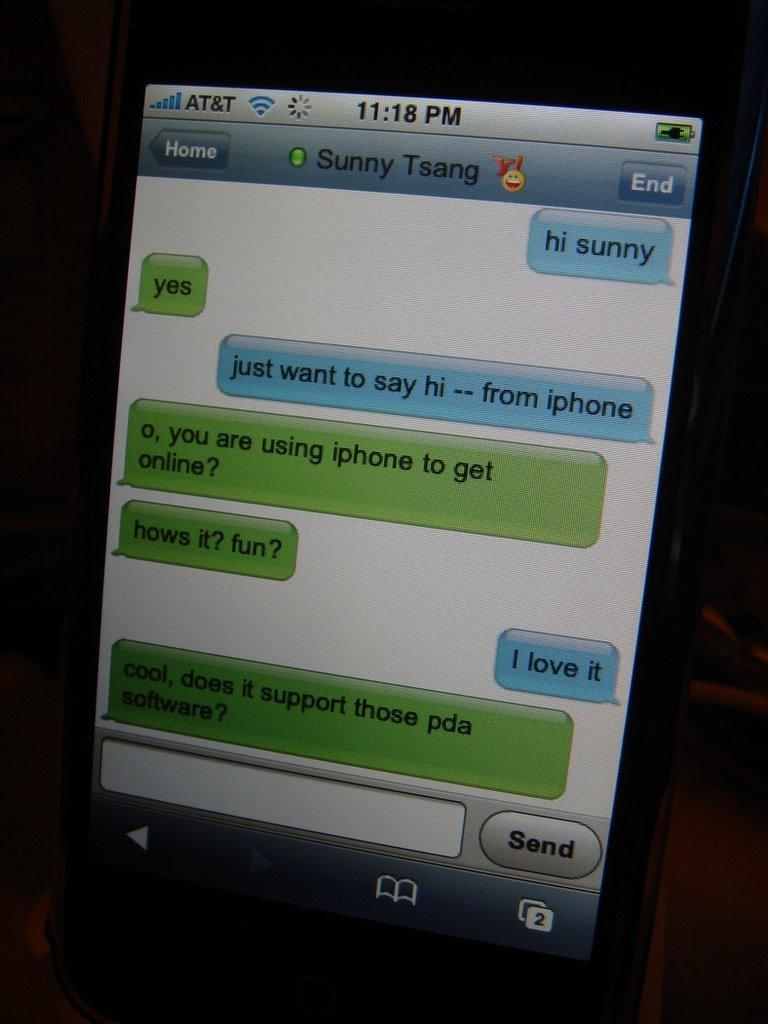<image>
Summarize the visual content of the image. sunny tsang's phone using at&t service texting with someone 